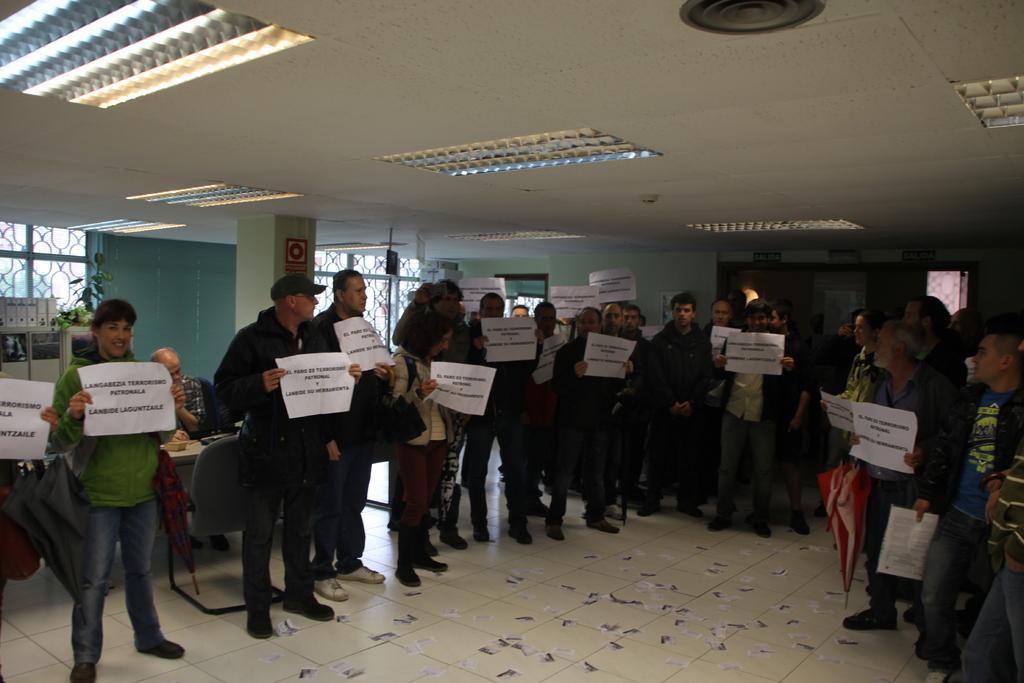Describe this image in one or two sentences. The picture is clicked inside a room. There are many people standing. They are holding paper. On the ceiling there are lights. In the background there are table , chairs,books, windows, doors. On the chair a person is sitting. Few people are holding umbrella. 